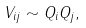<formula> <loc_0><loc_0><loc_500><loc_500>V _ { i j } \sim Q _ { i } Q _ { j } ,</formula> 